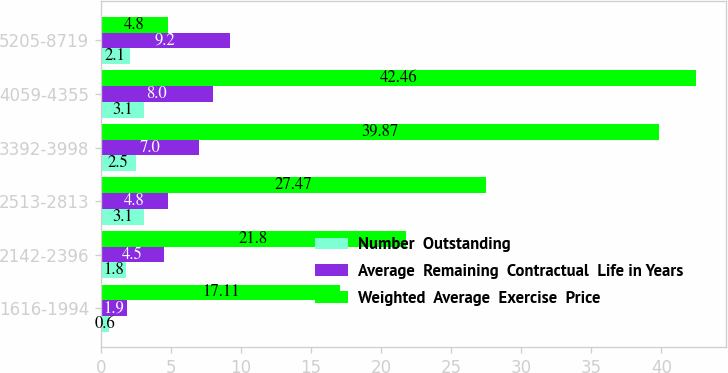<chart> <loc_0><loc_0><loc_500><loc_500><stacked_bar_chart><ecel><fcel>1616-1994<fcel>2142-2396<fcel>2513-2813<fcel>3392-3998<fcel>4059-4355<fcel>5205-8719<nl><fcel>Number  Outstanding<fcel>0.6<fcel>1.8<fcel>3.1<fcel>2.5<fcel>3.1<fcel>2.1<nl><fcel>Average  Remaining  Contractual  Life in Years<fcel>1.9<fcel>4.5<fcel>4.8<fcel>7<fcel>8<fcel>9.2<nl><fcel>Weighted  Average  Exercise  Price<fcel>17.11<fcel>21.8<fcel>27.47<fcel>39.87<fcel>42.46<fcel>4.8<nl></chart> 